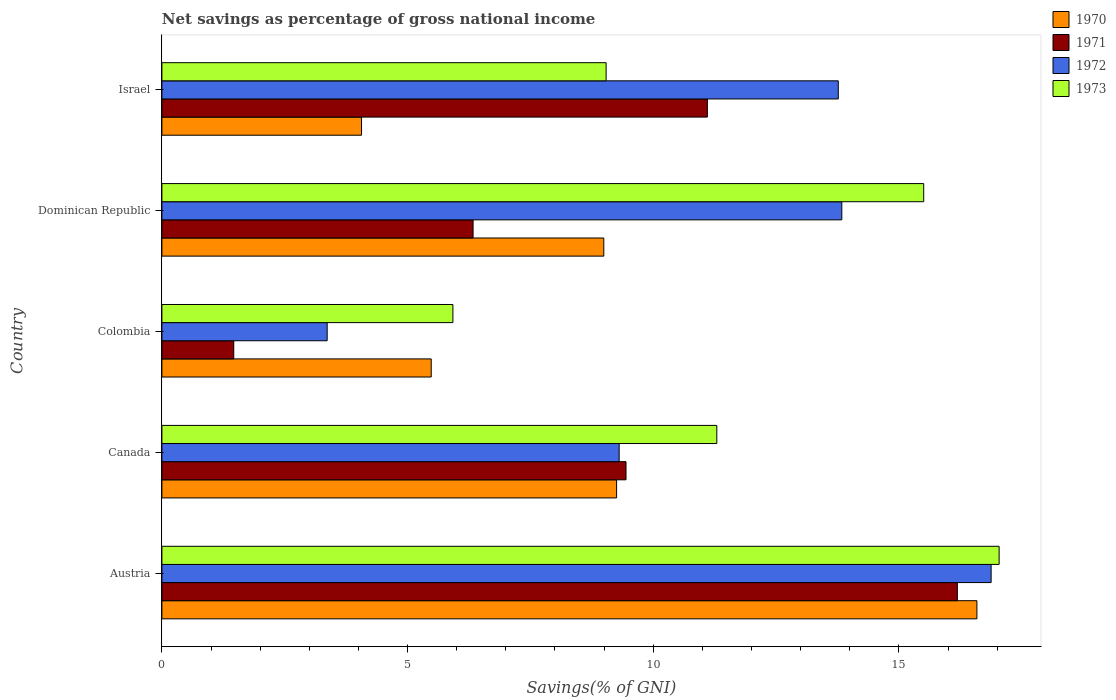How many groups of bars are there?
Offer a very short reply. 5. Are the number of bars per tick equal to the number of legend labels?
Your response must be concise. Yes. What is the label of the 2nd group of bars from the top?
Provide a short and direct response. Dominican Republic. What is the total savings in 1972 in Austria?
Keep it short and to the point. 16.88. Across all countries, what is the maximum total savings in 1973?
Offer a very short reply. 17.04. Across all countries, what is the minimum total savings in 1971?
Your response must be concise. 1.46. In which country was the total savings in 1970 maximum?
Ensure brevity in your answer.  Austria. In which country was the total savings in 1973 minimum?
Make the answer very short. Colombia. What is the total total savings in 1973 in the graph?
Offer a terse response. 58.8. What is the difference between the total savings in 1972 in Austria and that in Israel?
Offer a terse response. 3.11. What is the difference between the total savings in 1970 in Colombia and the total savings in 1972 in Canada?
Keep it short and to the point. -3.83. What is the average total savings in 1973 per country?
Offer a very short reply. 11.76. What is the difference between the total savings in 1970 and total savings in 1971 in Austria?
Your answer should be compact. 0.4. In how many countries, is the total savings in 1970 greater than 7 %?
Give a very brief answer. 3. What is the ratio of the total savings in 1971 in Austria to that in Canada?
Your response must be concise. 1.71. What is the difference between the highest and the second highest total savings in 1973?
Make the answer very short. 1.54. What is the difference between the highest and the lowest total savings in 1970?
Ensure brevity in your answer.  12.52. Is it the case that in every country, the sum of the total savings in 1970 and total savings in 1973 is greater than the sum of total savings in 1972 and total savings in 1971?
Offer a terse response. Yes. What does the 4th bar from the bottom in Israel represents?
Your answer should be very brief. 1973. Is it the case that in every country, the sum of the total savings in 1973 and total savings in 1971 is greater than the total savings in 1972?
Make the answer very short. Yes. How many bars are there?
Make the answer very short. 20. Are all the bars in the graph horizontal?
Offer a very short reply. Yes. Are the values on the major ticks of X-axis written in scientific E-notation?
Keep it short and to the point. No. Does the graph contain any zero values?
Make the answer very short. No. Does the graph contain grids?
Give a very brief answer. No. How many legend labels are there?
Provide a succinct answer. 4. How are the legend labels stacked?
Ensure brevity in your answer.  Vertical. What is the title of the graph?
Keep it short and to the point. Net savings as percentage of gross national income. Does "1962" appear as one of the legend labels in the graph?
Your response must be concise. No. What is the label or title of the X-axis?
Your answer should be compact. Savings(% of GNI). What is the label or title of the Y-axis?
Offer a terse response. Country. What is the Savings(% of GNI) in 1970 in Austria?
Offer a very short reply. 16.59. What is the Savings(% of GNI) of 1971 in Austria?
Your answer should be very brief. 16.19. What is the Savings(% of GNI) of 1972 in Austria?
Make the answer very short. 16.88. What is the Savings(% of GNI) of 1973 in Austria?
Offer a very short reply. 17.04. What is the Savings(% of GNI) in 1970 in Canada?
Offer a very short reply. 9.25. What is the Savings(% of GNI) in 1971 in Canada?
Ensure brevity in your answer.  9.45. What is the Savings(% of GNI) in 1972 in Canada?
Give a very brief answer. 9.31. What is the Savings(% of GNI) of 1973 in Canada?
Make the answer very short. 11.29. What is the Savings(% of GNI) in 1970 in Colombia?
Make the answer very short. 5.48. What is the Savings(% of GNI) in 1971 in Colombia?
Provide a succinct answer. 1.46. What is the Savings(% of GNI) of 1972 in Colombia?
Your response must be concise. 3.36. What is the Savings(% of GNI) of 1973 in Colombia?
Your answer should be compact. 5.92. What is the Savings(% of GNI) in 1970 in Dominican Republic?
Provide a short and direct response. 8.99. What is the Savings(% of GNI) in 1971 in Dominican Republic?
Make the answer very short. 6.33. What is the Savings(% of GNI) of 1972 in Dominican Republic?
Your answer should be compact. 13.84. What is the Savings(% of GNI) of 1973 in Dominican Republic?
Make the answer very short. 15.5. What is the Savings(% of GNI) of 1970 in Israel?
Your answer should be compact. 4.06. What is the Savings(% of GNI) of 1971 in Israel?
Your answer should be very brief. 11.1. What is the Savings(% of GNI) in 1972 in Israel?
Your response must be concise. 13.77. What is the Savings(% of GNI) in 1973 in Israel?
Keep it short and to the point. 9.04. Across all countries, what is the maximum Savings(% of GNI) of 1970?
Your response must be concise. 16.59. Across all countries, what is the maximum Savings(% of GNI) of 1971?
Offer a terse response. 16.19. Across all countries, what is the maximum Savings(% of GNI) of 1972?
Your response must be concise. 16.88. Across all countries, what is the maximum Savings(% of GNI) in 1973?
Make the answer very short. 17.04. Across all countries, what is the minimum Savings(% of GNI) of 1970?
Your response must be concise. 4.06. Across all countries, what is the minimum Savings(% of GNI) in 1971?
Give a very brief answer. 1.46. Across all countries, what is the minimum Savings(% of GNI) in 1972?
Offer a terse response. 3.36. Across all countries, what is the minimum Savings(% of GNI) in 1973?
Give a very brief answer. 5.92. What is the total Savings(% of GNI) in 1970 in the graph?
Your answer should be very brief. 44.38. What is the total Savings(% of GNI) of 1971 in the graph?
Offer a very short reply. 44.53. What is the total Savings(% of GNI) in 1972 in the graph?
Offer a terse response. 57.15. What is the total Savings(% of GNI) in 1973 in the graph?
Provide a succinct answer. 58.8. What is the difference between the Savings(% of GNI) in 1970 in Austria and that in Canada?
Keep it short and to the point. 7.33. What is the difference between the Savings(% of GNI) of 1971 in Austria and that in Canada?
Your answer should be very brief. 6.74. What is the difference between the Savings(% of GNI) in 1972 in Austria and that in Canada?
Offer a terse response. 7.57. What is the difference between the Savings(% of GNI) in 1973 in Austria and that in Canada?
Provide a succinct answer. 5.75. What is the difference between the Savings(% of GNI) of 1970 in Austria and that in Colombia?
Your answer should be compact. 11.11. What is the difference between the Savings(% of GNI) of 1971 in Austria and that in Colombia?
Your response must be concise. 14.73. What is the difference between the Savings(% of GNI) of 1972 in Austria and that in Colombia?
Make the answer very short. 13.51. What is the difference between the Savings(% of GNI) of 1973 in Austria and that in Colombia?
Your answer should be compact. 11.12. What is the difference between the Savings(% of GNI) in 1970 in Austria and that in Dominican Republic?
Provide a short and direct response. 7.59. What is the difference between the Savings(% of GNI) in 1971 in Austria and that in Dominican Republic?
Give a very brief answer. 9.86. What is the difference between the Savings(% of GNI) of 1972 in Austria and that in Dominican Republic?
Provide a succinct answer. 3.04. What is the difference between the Savings(% of GNI) of 1973 in Austria and that in Dominican Republic?
Keep it short and to the point. 1.54. What is the difference between the Savings(% of GNI) in 1970 in Austria and that in Israel?
Provide a succinct answer. 12.52. What is the difference between the Savings(% of GNI) in 1971 in Austria and that in Israel?
Offer a very short reply. 5.09. What is the difference between the Savings(% of GNI) of 1972 in Austria and that in Israel?
Provide a short and direct response. 3.11. What is the difference between the Savings(% of GNI) of 1973 in Austria and that in Israel?
Provide a succinct answer. 8. What is the difference between the Savings(% of GNI) of 1970 in Canada and that in Colombia?
Your response must be concise. 3.77. What is the difference between the Savings(% of GNI) of 1971 in Canada and that in Colombia?
Ensure brevity in your answer.  7.98. What is the difference between the Savings(% of GNI) in 1972 in Canada and that in Colombia?
Offer a terse response. 5.94. What is the difference between the Savings(% of GNI) of 1973 in Canada and that in Colombia?
Your answer should be very brief. 5.37. What is the difference between the Savings(% of GNI) in 1970 in Canada and that in Dominican Republic?
Offer a very short reply. 0.26. What is the difference between the Savings(% of GNI) in 1971 in Canada and that in Dominican Republic?
Keep it short and to the point. 3.11. What is the difference between the Savings(% of GNI) in 1972 in Canada and that in Dominican Republic?
Offer a very short reply. -4.53. What is the difference between the Savings(% of GNI) in 1973 in Canada and that in Dominican Republic?
Your answer should be very brief. -4.21. What is the difference between the Savings(% of GNI) of 1970 in Canada and that in Israel?
Give a very brief answer. 5.19. What is the difference between the Savings(% of GNI) of 1971 in Canada and that in Israel?
Give a very brief answer. -1.66. What is the difference between the Savings(% of GNI) in 1972 in Canada and that in Israel?
Ensure brevity in your answer.  -4.46. What is the difference between the Savings(% of GNI) in 1973 in Canada and that in Israel?
Ensure brevity in your answer.  2.25. What is the difference between the Savings(% of GNI) of 1970 in Colombia and that in Dominican Republic?
Provide a short and direct response. -3.51. What is the difference between the Savings(% of GNI) of 1971 in Colombia and that in Dominican Republic?
Provide a short and direct response. -4.87. What is the difference between the Savings(% of GNI) in 1972 in Colombia and that in Dominican Republic?
Your answer should be compact. -10.47. What is the difference between the Savings(% of GNI) in 1973 in Colombia and that in Dominican Republic?
Offer a very short reply. -9.58. What is the difference between the Savings(% of GNI) of 1970 in Colombia and that in Israel?
Ensure brevity in your answer.  1.42. What is the difference between the Savings(% of GNI) of 1971 in Colombia and that in Israel?
Your answer should be very brief. -9.64. What is the difference between the Savings(% of GNI) in 1972 in Colombia and that in Israel?
Make the answer very short. -10.4. What is the difference between the Savings(% of GNI) of 1973 in Colombia and that in Israel?
Your answer should be compact. -3.12. What is the difference between the Savings(% of GNI) of 1970 in Dominican Republic and that in Israel?
Provide a short and direct response. 4.93. What is the difference between the Savings(% of GNI) of 1971 in Dominican Republic and that in Israel?
Keep it short and to the point. -4.77. What is the difference between the Savings(% of GNI) of 1972 in Dominican Republic and that in Israel?
Your answer should be very brief. 0.07. What is the difference between the Savings(% of GNI) of 1973 in Dominican Republic and that in Israel?
Your answer should be very brief. 6.46. What is the difference between the Savings(% of GNI) in 1970 in Austria and the Savings(% of GNI) in 1971 in Canada?
Offer a very short reply. 7.14. What is the difference between the Savings(% of GNI) in 1970 in Austria and the Savings(% of GNI) in 1972 in Canada?
Provide a succinct answer. 7.28. What is the difference between the Savings(% of GNI) of 1970 in Austria and the Savings(% of GNI) of 1973 in Canada?
Give a very brief answer. 5.29. What is the difference between the Savings(% of GNI) in 1971 in Austria and the Savings(% of GNI) in 1972 in Canada?
Your answer should be very brief. 6.88. What is the difference between the Savings(% of GNI) in 1971 in Austria and the Savings(% of GNI) in 1973 in Canada?
Your response must be concise. 4.9. What is the difference between the Savings(% of GNI) of 1972 in Austria and the Savings(% of GNI) of 1973 in Canada?
Offer a very short reply. 5.58. What is the difference between the Savings(% of GNI) in 1970 in Austria and the Savings(% of GNI) in 1971 in Colombia?
Keep it short and to the point. 15.12. What is the difference between the Savings(% of GNI) in 1970 in Austria and the Savings(% of GNI) in 1972 in Colombia?
Provide a succinct answer. 13.22. What is the difference between the Savings(% of GNI) in 1970 in Austria and the Savings(% of GNI) in 1973 in Colombia?
Your answer should be very brief. 10.66. What is the difference between the Savings(% of GNI) in 1971 in Austria and the Savings(% of GNI) in 1972 in Colombia?
Your response must be concise. 12.83. What is the difference between the Savings(% of GNI) in 1971 in Austria and the Savings(% of GNI) in 1973 in Colombia?
Your answer should be very brief. 10.27. What is the difference between the Savings(% of GNI) of 1972 in Austria and the Savings(% of GNI) of 1973 in Colombia?
Offer a very short reply. 10.95. What is the difference between the Savings(% of GNI) of 1970 in Austria and the Savings(% of GNI) of 1971 in Dominican Republic?
Make the answer very short. 10.25. What is the difference between the Savings(% of GNI) of 1970 in Austria and the Savings(% of GNI) of 1972 in Dominican Republic?
Make the answer very short. 2.75. What is the difference between the Savings(% of GNI) of 1970 in Austria and the Savings(% of GNI) of 1973 in Dominican Republic?
Your response must be concise. 1.08. What is the difference between the Savings(% of GNI) of 1971 in Austria and the Savings(% of GNI) of 1972 in Dominican Republic?
Offer a very short reply. 2.35. What is the difference between the Savings(% of GNI) in 1971 in Austria and the Savings(% of GNI) in 1973 in Dominican Republic?
Offer a very short reply. 0.69. What is the difference between the Savings(% of GNI) in 1972 in Austria and the Savings(% of GNI) in 1973 in Dominican Republic?
Offer a very short reply. 1.37. What is the difference between the Savings(% of GNI) of 1970 in Austria and the Savings(% of GNI) of 1971 in Israel?
Your answer should be compact. 5.49. What is the difference between the Savings(% of GNI) in 1970 in Austria and the Savings(% of GNI) in 1972 in Israel?
Make the answer very short. 2.82. What is the difference between the Savings(% of GNI) of 1970 in Austria and the Savings(% of GNI) of 1973 in Israel?
Make the answer very short. 7.55. What is the difference between the Savings(% of GNI) in 1971 in Austria and the Savings(% of GNI) in 1972 in Israel?
Give a very brief answer. 2.42. What is the difference between the Savings(% of GNI) in 1971 in Austria and the Savings(% of GNI) in 1973 in Israel?
Your response must be concise. 7.15. What is the difference between the Savings(% of GNI) in 1972 in Austria and the Savings(% of GNI) in 1973 in Israel?
Provide a short and direct response. 7.84. What is the difference between the Savings(% of GNI) in 1970 in Canada and the Savings(% of GNI) in 1971 in Colombia?
Offer a terse response. 7.79. What is the difference between the Savings(% of GNI) in 1970 in Canada and the Savings(% of GNI) in 1972 in Colombia?
Keep it short and to the point. 5.89. What is the difference between the Savings(% of GNI) of 1970 in Canada and the Savings(% of GNI) of 1973 in Colombia?
Offer a terse response. 3.33. What is the difference between the Savings(% of GNI) in 1971 in Canada and the Savings(% of GNI) in 1972 in Colombia?
Your answer should be compact. 6.08. What is the difference between the Savings(% of GNI) in 1971 in Canada and the Savings(% of GNI) in 1973 in Colombia?
Keep it short and to the point. 3.52. What is the difference between the Savings(% of GNI) of 1972 in Canada and the Savings(% of GNI) of 1973 in Colombia?
Your answer should be compact. 3.38. What is the difference between the Savings(% of GNI) of 1970 in Canada and the Savings(% of GNI) of 1971 in Dominican Republic?
Offer a terse response. 2.92. What is the difference between the Savings(% of GNI) in 1970 in Canada and the Savings(% of GNI) in 1972 in Dominican Republic?
Your response must be concise. -4.58. What is the difference between the Savings(% of GNI) in 1970 in Canada and the Savings(% of GNI) in 1973 in Dominican Republic?
Offer a very short reply. -6.25. What is the difference between the Savings(% of GNI) of 1971 in Canada and the Savings(% of GNI) of 1972 in Dominican Republic?
Your response must be concise. -4.39. What is the difference between the Savings(% of GNI) in 1971 in Canada and the Savings(% of GNI) in 1973 in Dominican Republic?
Your answer should be compact. -6.06. What is the difference between the Savings(% of GNI) in 1972 in Canada and the Savings(% of GNI) in 1973 in Dominican Republic?
Offer a very short reply. -6.2. What is the difference between the Savings(% of GNI) of 1970 in Canada and the Savings(% of GNI) of 1971 in Israel?
Provide a short and direct response. -1.85. What is the difference between the Savings(% of GNI) of 1970 in Canada and the Savings(% of GNI) of 1972 in Israel?
Your response must be concise. -4.51. What is the difference between the Savings(% of GNI) of 1970 in Canada and the Savings(% of GNI) of 1973 in Israel?
Offer a very short reply. 0.21. What is the difference between the Savings(% of GNI) of 1971 in Canada and the Savings(% of GNI) of 1972 in Israel?
Your response must be concise. -4.32. What is the difference between the Savings(% of GNI) in 1971 in Canada and the Savings(% of GNI) in 1973 in Israel?
Keep it short and to the point. 0.4. What is the difference between the Savings(% of GNI) in 1972 in Canada and the Savings(% of GNI) in 1973 in Israel?
Provide a succinct answer. 0.27. What is the difference between the Savings(% of GNI) of 1970 in Colombia and the Savings(% of GNI) of 1971 in Dominican Republic?
Make the answer very short. -0.85. What is the difference between the Savings(% of GNI) of 1970 in Colombia and the Savings(% of GNI) of 1972 in Dominican Republic?
Make the answer very short. -8.36. What is the difference between the Savings(% of GNI) in 1970 in Colombia and the Savings(% of GNI) in 1973 in Dominican Republic?
Provide a short and direct response. -10.02. What is the difference between the Savings(% of GNI) of 1971 in Colombia and the Savings(% of GNI) of 1972 in Dominican Republic?
Make the answer very short. -12.38. What is the difference between the Savings(% of GNI) of 1971 in Colombia and the Savings(% of GNI) of 1973 in Dominican Republic?
Your answer should be very brief. -14.04. What is the difference between the Savings(% of GNI) in 1972 in Colombia and the Savings(% of GNI) in 1973 in Dominican Republic?
Give a very brief answer. -12.14. What is the difference between the Savings(% of GNI) in 1970 in Colombia and the Savings(% of GNI) in 1971 in Israel?
Your answer should be very brief. -5.62. What is the difference between the Savings(% of GNI) in 1970 in Colombia and the Savings(% of GNI) in 1972 in Israel?
Your answer should be very brief. -8.28. What is the difference between the Savings(% of GNI) in 1970 in Colombia and the Savings(% of GNI) in 1973 in Israel?
Offer a very short reply. -3.56. What is the difference between the Savings(% of GNI) in 1971 in Colombia and the Savings(% of GNI) in 1972 in Israel?
Your answer should be very brief. -12.3. What is the difference between the Savings(% of GNI) of 1971 in Colombia and the Savings(% of GNI) of 1973 in Israel?
Give a very brief answer. -7.58. What is the difference between the Savings(% of GNI) of 1972 in Colombia and the Savings(% of GNI) of 1973 in Israel?
Offer a very short reply. -5.68. What is the difference between the Savings(% of GNI) of 1970 in Dominican Republic and the Savings(% of GNI) of 1971 in Israel?
Provide a short and direct response. -2.11. What is the difference between the Savings(% of GNI) of 1970 in Dominican Republic and the Savings(% of GNI) of 1972 in Israel?
Give a very brief answer. -4.77. What is the difference between the Savings(% of GNI) in 1970 in Dominican Republic and the Savings(% of GNI) in 1973 in Israel?
Offer a terse response. -0.05. What is the difference between the Savings(% of GNI) in 1971 in Dominican Republic and the Savings(% of GNI) in 1972 in Israel?
Make the answer very short. -7.43. What is the difference between the Savings(% of GNI) of 1971 in Dominican Republic and the Savings(% of GNI) of 1973 in Israel?
Give a very brief answer. -2.71. What is the difference between the Savings(% of GNI) in 1972 in Dominican Republic and the Savings(% of GNI) in 1973 in Israel?
Make the answer very short. 4.8. What is the average Savings(% of GNI) of 1970 per country?
Offer a terse response. 8.88. What is the average Savings(% of GNI) in 1971 per country?
Your response must be concise. 8.91. What is the average Savings(% of GNI) in 1972 per country?
Make the answer very short. 11.43. What is the average Savings(% of GNI) in 1973 per country?
Your answer should be compact. 11.76. What is the difference between the Savings(% of GNI) in 1970 and Savings(% of GNI) in 1971 in Austria?
Ensure brevity in your answer.  0.4. What is the difference between the Savings(% of GNI) of 1970 and Savings(% of GNI) of 1972 in Austria?
Keep it short and to the point. -0.29. What is the difference between the Savings(% of GNI) in 1970 and Savings(% of GNI) in 1973 in Austria?
Your answer should be very brief. -0.45. What is the difference between the Savings(% of GNI) of 1971 and Savings(% of GNI) of 1972 in Austria?
Ensure brevity in your answer.  -0.69. What is the difference between the Savings(% of GNI) of 1971 and Savings(% of GNI) of 1973 in Austria?
Make the answer very short. -0.85. What is the difference between the Savings(% of GNI) of 1972 and Savings(% of GNI) of 1973 in Austria?
Your answer should be compact. -0.16. What is the difference between the Savings(% of GNI) in 1970 and Savings(% of GNI) in 1971 in Canada?
Make the answer very short. -0.19. What is the difference between the Savings(% of GNI) of 1970 and Savings(% of GNI) of 1972 in Canada?
Provide a succinct answer. -0.05. What is the difference between the Savings(% of GNI) of 1970 and Savings(% of GNI) of 1973 in Canada?
Offer a terse response. -2.04. What is the difference between the Savings(% of GNI) in 1971 and Savings(% of GNI) in 1972 in Canada?
Your answer should be very brief. 0.14. What is the difference between the Savings(% of GNI) in 1971 and Savings(% of GNI) in 1973 in Canada?
Ensure brevity in your answer.  -1.85. What is the difference between the Savings(% of GNI) in 1972 and Savings(% of GNI) in 1973 in Canada?
Offer a terse response. -1.99. What is the difference between the Savings(% of GNI) in 1970 and Savings(% of GNI) in 1971 in Colombia?
Your answer should be very brief. 4.02. What is the difference between the Savings(% of GNI) of 1970 and Savings(% of GNI) of 1972 in Colombia?
Offer a terse response. 2.12. What is the difference between the Savings(% of GNI) of 1970 and Savings(% of GNI) of 1973 in Colombia?
Offer a terse response. -0.44. What is the difference between the Savings(% of GNI) of 1971 and Savings(% of GNI) of 1972 in Colombia?
Provide a succinct answer. -1.9. What is the difference between the Savings(% of GNI) of 1971 and Savings(% of GNI) of 1973 in Colombia?
Keep it short and to the point. -4.46. What is the difference between the Savings(% of GNI) of 1972 and Savings(% of GNI) of 1973 in Colombia?
Ensure brevity in your answer.  -2.56. What is the difference between the Savings(% of GNI) of 1970 and Savings(% of GNI) of 1971 in Dominican Republic?
Offer a terse response. 2.66. What is the difference between the Savings(% of GNI) in 1970 and Savings(% of GNI) in 1972 in Dominican Republic?
Provide a short and direct response. -4.84. What is the difference between the Savings(% of GNI) in 1970 and Savings(% of GNI) in 1973 in Dominican Republic?
Provide a succinct answer. -6.51. What is the difference between the Savings(% of GNI) of 1971 and Savings(% of GNI) of 1972 in Dominican Republic?
Offer a very short reply. -7.5. What is the difference between the Savings(% of GNI) in 1971 and Savings(% of GNI) in 1973 in Dominican Republic?
Ensure brevity in your answer.  -9.17. What is the difference between the Savings(% of GNI) of 1972 and Savings(% of GNI) of 1973 in Dominican Republic?
Your answer should be very brief. -1.67. What is the difference between the Savings(% of GNI) in 1970 and Savings(% of GNI) in 1971 in Israel?
Offer a very short reply. -7.04. What is the difference between the Savings(% of GNI) in 1970 and Savings(% of GNI) in 1972 in Israel?
Your answer should be compact. -9.7. What is the difference between the Savings(% of GNI) in 1970 and Savings(% of GNI) in 1973 in Israel?
Provide a succinct answer. -4.98. What is the difference between the Savings(% of GNI) in 1971 and Savings(% of GNI) in 1972 in Israel?
Your answer should be very brief. -2.66. What is the difference between the Savings(% of GNI) of 1971 and Savings(% of GNI) of 1973 in Israel?
Make the answer very short. 2.06. What is the difference between the Savings(% of GNI) of 1972 and Savings(% of GNI) of 1973 in Israel?
Provide a succinct answer. 4.73. What is the ratio of the Savings(% of GNI) in 1970 in Austria to that in Canada?
Your answer should be compact. 1.79. What is the ratio of the Savings(% of GNI) in 1971 in Austria to that in Canada?
Your response must be concise. 1.71. What is the ratio of the Savings(% of GNI) of 1972 in Austria to that in Canada?
Your answer should be compact. 1.81. What is the ratio of the Savings(% of GNI) of 1973 in Austria to that in Canada?
Give a very brief answer. 1.51. What is the ratio of the Savings(% of GNI) of 1970 in Austria to that in Colombia?
Keep it short and to the point. 3.03. What is the ratio of the Savings(% of GNI) of 1971 in Austria to that in Colombia?
Your response must be concise. 11.07. What is the ratio of the Savings(% of GNI) of 1972 in Austria to that in Colombia?
Offer a terse response. 5.02. What is the ratio of the Savings(% of GNI) of 1973 in Austria to that in Colombia?
Give a very brief answer. 2.88. What is the ratio of the Savings(% of GNI) of 1970 in Austria to that in Dominican Republic?
Offer a very short reply. 1.84. What is the ratio of the Savings(% of GNI) in 1971 in Austria to that in Dominican Republic?
Give a very brief answer. 2.56. What is the ratio of the Savings(% of GNI) of 1972 in Austria to that in Dominican Republic?
Offer a terse response. 1.22. What is the ratio of the Savings(% of GNI) in 1973 in Austria to that in Dominican Republic?
Offer a very short reply. 1.1. What is the ratio of the Savings(% of GNI) of 1970 in Austria to that in Israel?
Give a very brief answer. 4.08. What is the ratio of the Savings(% of GNI) of 1971 in Austria to that in Israel?
Provide a succinct answer. 1.46. What is the ratio of the Savings(% of GNI) in 1972 in Austria to that in Israel?
Ensure brevity in your answer.  1.23. What is the ratio of the Savings(% of GNI) of 1973 in Austria to that in Israel?
Your answer should be very brief. 1.88. What is the ratio of the Savings(% of GNI) of 1970 in Canada to that in Colombia?
Give a very brief answer. 1.69. What is the ratio of the Savings(% of GNI) of 1971 in Canada to that in Colombia?
Offer a terse response. 6.46. What is the ratio of the Savings(% of GNI) of 1972 in Canada to that in Colombia?
Give a very brief answer. 2.77. What is the ratio of the Savings(% of GNI) of 1973 in Canada to that in Colombia?
Your answer should be compact. 1.91. What is the ratio of the Savings(% of GNI) in 1970 in Canada to that in Dominican Republic?
Keep it short and to the point. 1.03. What is the ratio of the Savings(% of GNI) of 1971 in Canada to that in Dominican Republic?
Your answer should be very brief. 1.49. What is the ratio of the Savings(% of GNI) in 1972 in Canada to that in Dominican Republic?
Give a very brief answer. 0.67. What is the ratio of the Savings(% of GNI) in 1973 in Canada to that in Dominican Republic?
Provide a short and direct response. 0.73. What is the ratio of the Savings(% of GNI) in 1970 in Canada to that in Israel?
Provide a short and direct response. 2.28. What is the ratio of the Savings(% of GNI) in 1971 in Canada to that in Israel?
Provide a short and direct response. 0.85. What is the ratio of the Savings(% of GNI) in 1972 in Canada to that in Israel?
Offer a very short reply. 0.68. What is the ratio of the Savings(% of GNI) in 1973 in Canada to that in Israel?
Make the answer very short. 1.25. What is the ratio of the Savings(% of GNI) of 1970 in Colombia to that in Dominican Republic?
Your response must be concise. 0.61. What is the ratio of the Savings(% of GNI) of 1971 in Colombia to that in Dominican Republic?
Provide a succinct answer. 0.23. What is the ratio of the Savings(% of GNI) in 1972 in Colombia to that in Dominican Republic?
Ensure brevity in your answer.  0.24. What is the ratio of the Savings(% of GNI) in 1973 in Colombia to that in Dominican Republic?
Give a very brief answer. 0.38. What is the ratio of the Savings(% of GNI) in 1970 in Colombia to that in Israel?
Ensure brevity in your answer.  1.35. What is the ratio of the Savings(% of GNI) in 1971 in Colombia to that in Israel?
Offer a very short reply. 0.13. What is the ratio of the Savings(% of GNI) in 1972 in Colombia to that in Israel?
Keep it short and to the point. 0.24. What is the ratio of the Savings(% of GNI) of 1973 in Colombia to that in Israel?
Provide a short and direct response. 0.66. What is the ratio of the Savings(% of GNI) of 1970 in Dominican Republic to that in Israel?
Your answer should be very brief. 2.21. What is the ratio of the Savings(% of GNI) in 1971 in Dominican Republic to that in Israel?
Offer a very short reply. 0.57. What is the ratio of the Savings(% of GNI) of 1972 in Dominican Republic to that in Israel?
Your answer should be compact. 1.01. What is the ratio of the Savings(% of GNI) in 1973 in Dominican Republic to that in Israel?
Keep it short and to the point. 1.71. What is the difference between the highest and the second highest Savings(% of GNI) in 1970?
Provide a short and direct response. 7.33. What is the difference between the highest and the second highest Savings(% of GNI) of 1971?
Ensure brevity in your answer.  5.09. What is the difference between the highest and the second highest Savings(% of GNI) in 1972?
Provide a succinct answer. 3.04. What is the difference between the highest and the second highest Savings(% of GNI) of 1973?
Make the answer very short. 1.54. What is the difference between the highest and the lowest Savings(% of GNI) in 1970?
Provide a short and direct response. 12.52. What is the difference between the highest and the lowest Savings(% of GNI) in 1971?
Your response must be concise. 14.73. What is the difference between the highest and the lowest Savings(% of GNI) of 1972?
Provide a succinct answer. 13.51. What is the difference between the highest and the lowest Savings(% of GNI) in 1973?
Keep it short and to the point. 11.12. 